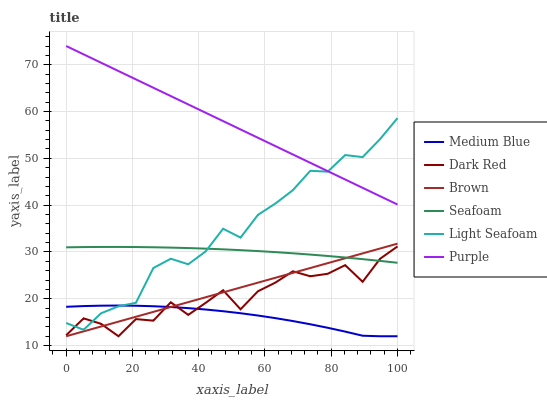Does Medium Blue have the minimum area under the curve?
Answer yes or no. Yes. Does Purple have the maximum area under the curve?
Answer yes or no. Yes. Does Dark Red have the minimum area under the curve?
Answer yes or no. No. Does Dark Red have the maximum area under the curve?
Answer yes or no. No. Is Purple the smoothest?
Answer yes or no. Yes. Is Dark Red the roughest?
Answer yes or no. Yes. Is Dark Red the smoothest?
Answer yes or no. No. Is Purple the roughest?
Answer yes or no. No. Does Brown have the lowest value?
Answer yes or no. Yes. Does Purple have the lowest value?
Answer yes or no. No. Does Purple have the highest value?
Answer yes or no. Yes. Does Dark Red have the highest value?
Answer yes or no. No. Is Brown less than Purple?
Answer yes or no. Yes. Is Purple greater than Medium Blue?
Answer yes or no. Yes. Does Medium Blue intersect Light Seafoam?
Answer yes or no. Yes. Is Medium Blue less than Light Seafoam?
Answer yes or no. No. Is Medium Blue greater than Light Seafoam?
Answer yes or no. No. Does Brown intersect Purple?
Answer yes or no. No. 